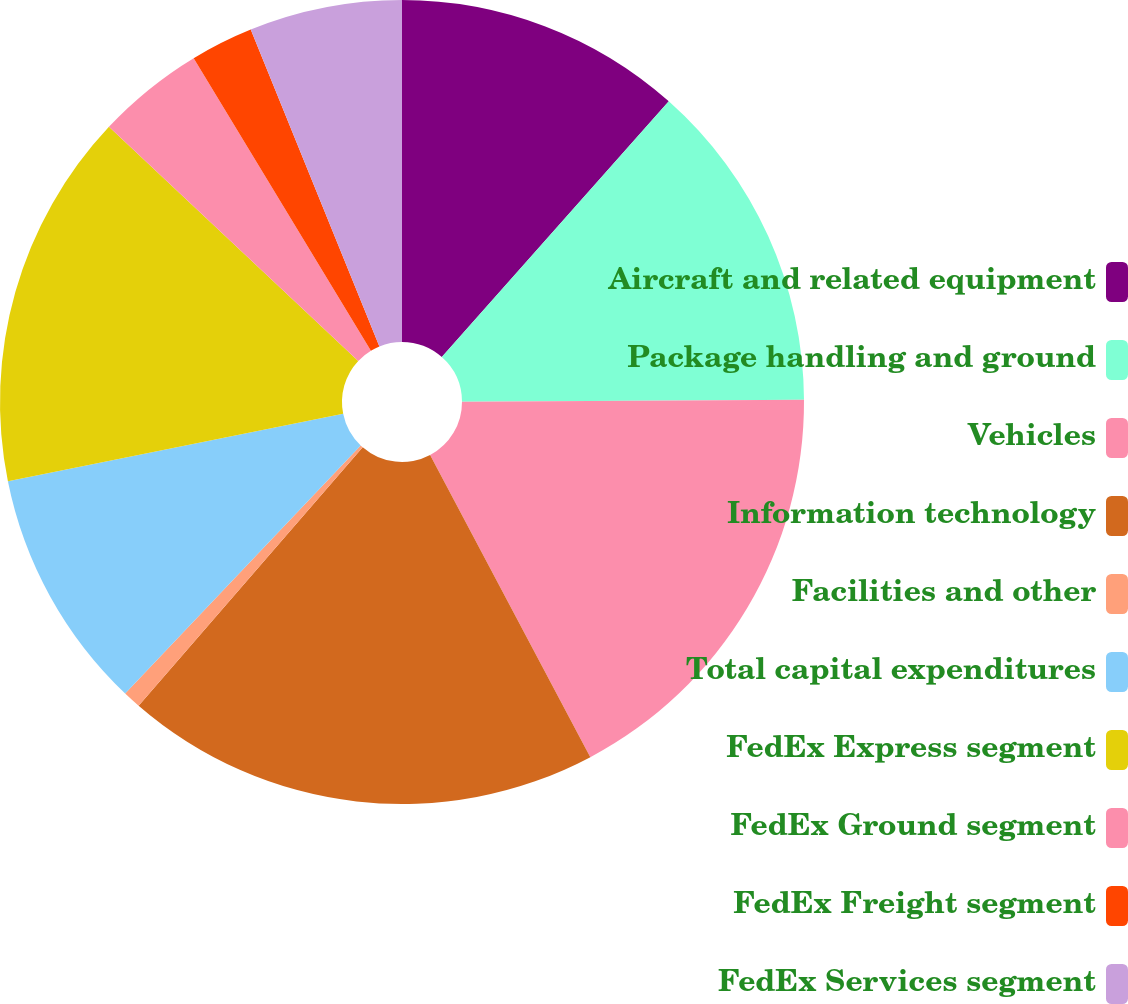Convert chart to OTSL. <chart><loc_0><loc_0><loc_500><loc_500><pie_chart><fcel>Aircraft and related equipment<fcel>Package handling and ground<fcel>Vehicles<fcel>Information technology<fcel>Facilities and other<fcel>Total capital expenditures<fcel>FedEx Express segment<fcel>FedEx Ground segment<fcel>FedEx Freight segment<fcel>FedEx Services segment<nl><fcel>11.55%<fcel>13.36%<fcel>17.33%<fcel>19.13%<fcel>0.72%<fcel>9.75%<fcel>15.16%<fcel>4.33%<fcel>2.53%<fcel>6.14%<nl></chart> 